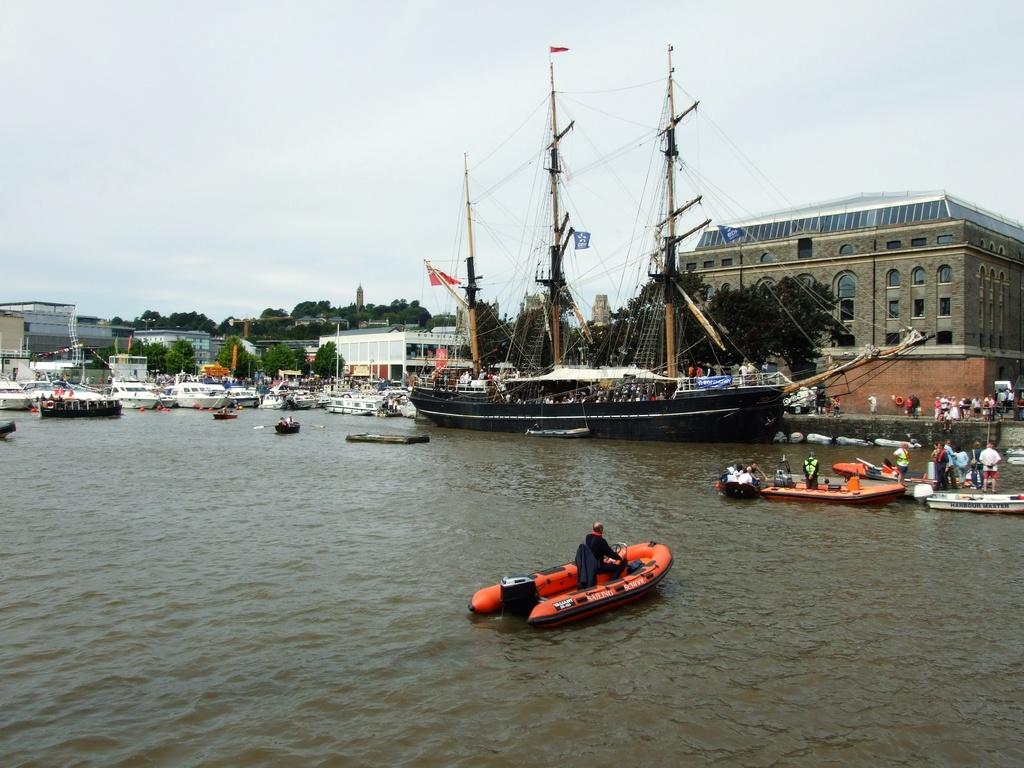What is on the water in the image? There are boats on the water in the image. Who or what is in the boats? There are people in the boats. What can be seen in the background of the image? There are trees, buildings, and the sky visible in the background. What type of canvas is being used by the people in the boats? There is no canvas present in the image; the people are in boats on the water. 